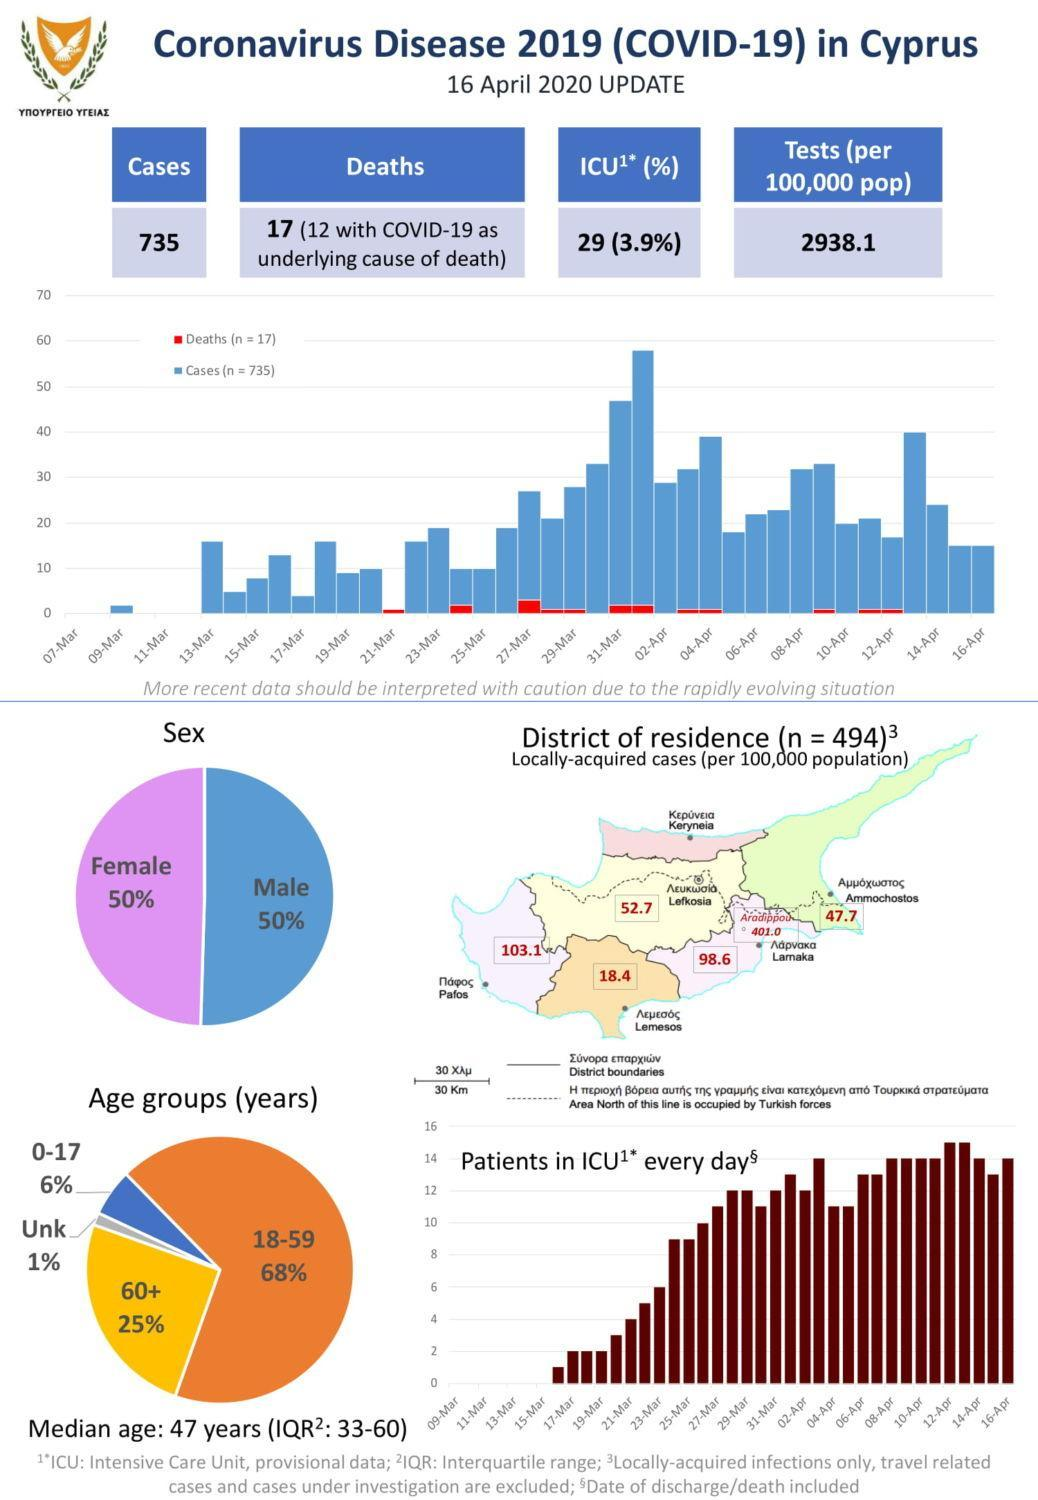What percent are senior citizens according to the pie chart?
Answer the question with a short phrase. 25% 